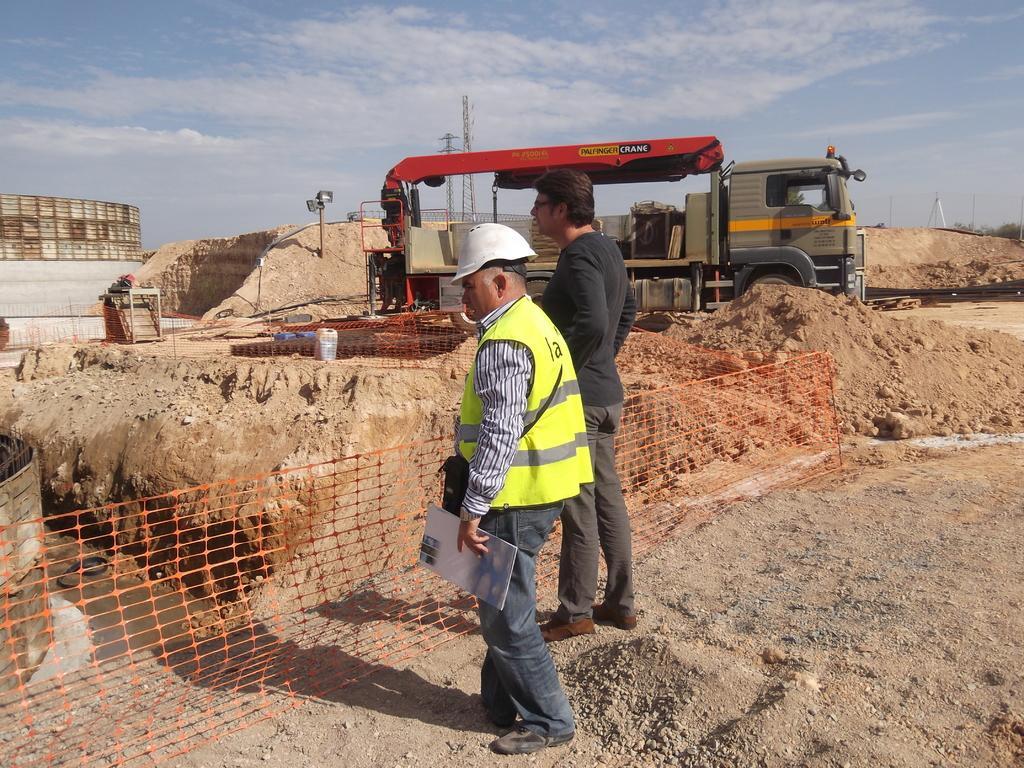How would you summarize this image in a sentence or two? In this image I can see two people standing one is wearing a helmet and holding a pad in his hand I can see sand all over the area. I can see a crane and area under construction and I can see the sky at the top of the image.  